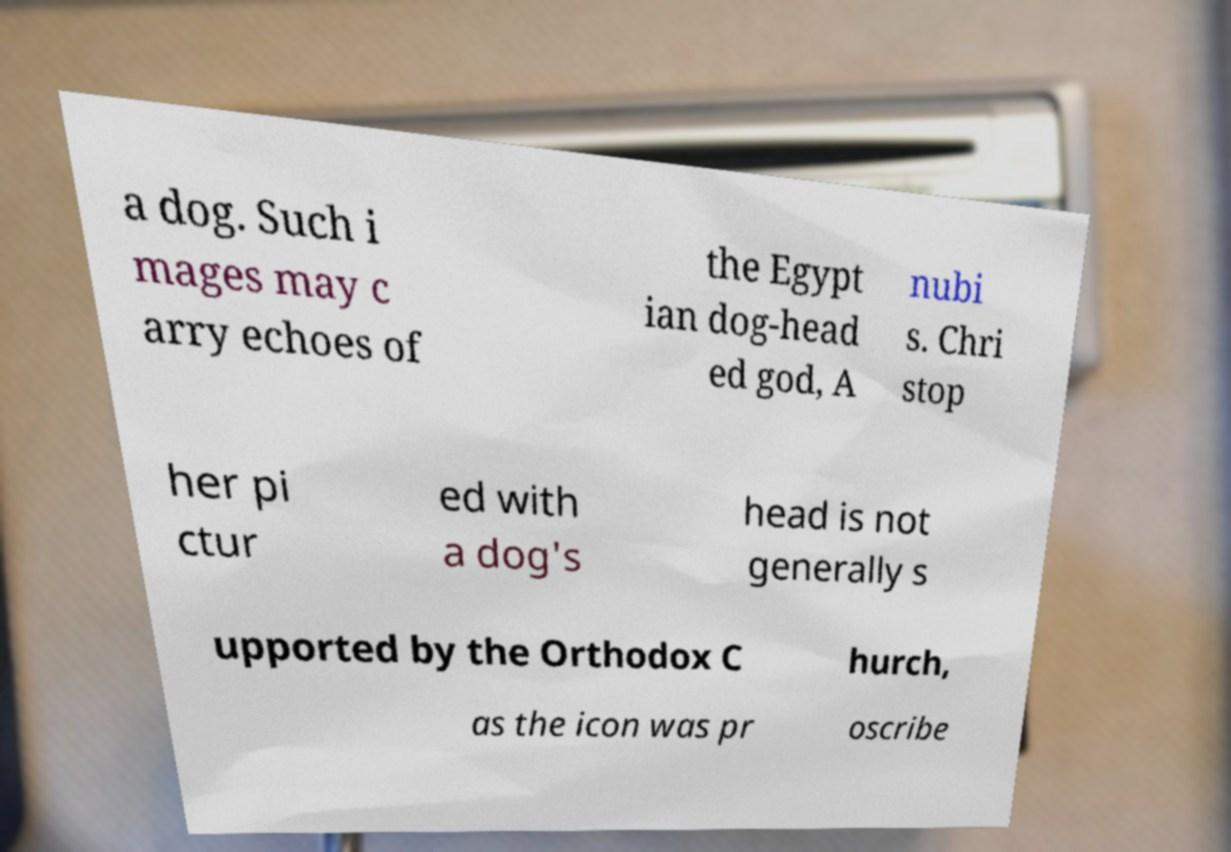Can you read and provide the text displayed in the image?This photo seems to have some interesting text. Can you extract and type it out for me? a dog. Such i mages may c arry echoes of the Egypt ian dog-head ed god, A nubi s. Chri stop her pi ctur ed with a dog's head is not generally s upported by the Orthodox C hurch, as the icon was pr oscribe 